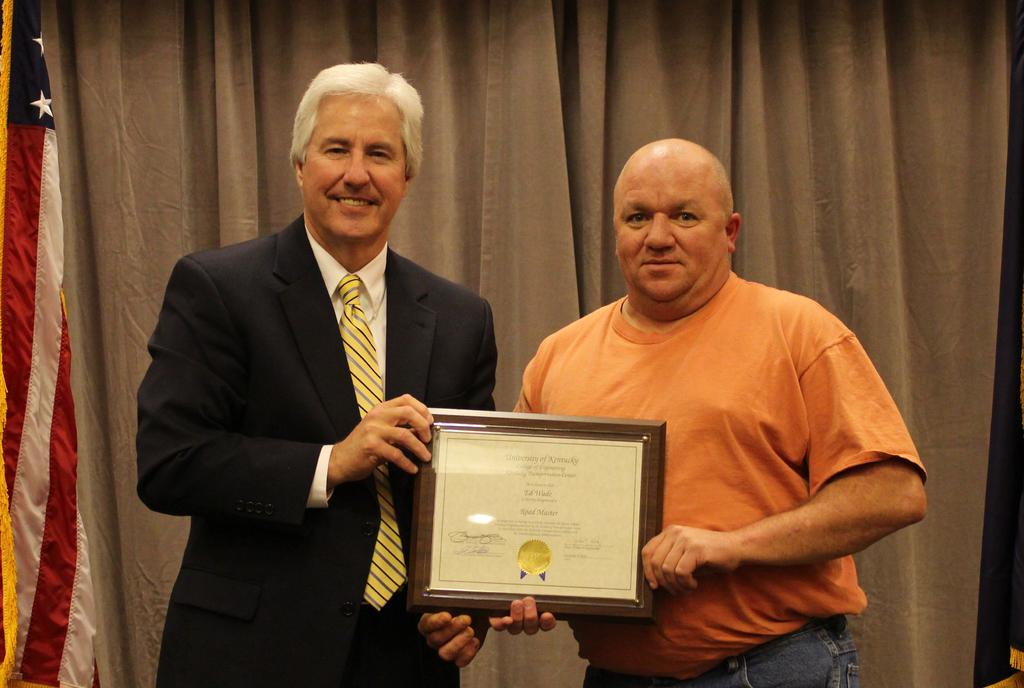How many people are present in the image? There are two persons in the image. What are the two persons doing in the image? The two persons are holding an object. What can be seen in the background of the image? There are curtains in the background of the image. What type of mountain can be seen in the background of the image? There is no mountain present in the background of the image; it features curtains instead. 